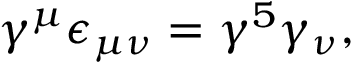Convert formula to latex. <formula><loc_0><loc_0><loc_500><loc_500>\gamma ^ { \mu } \epsilon _ { \mu \nu } = \gamma ^ { 5 } \gamma _ { \nu } ,</formula> 